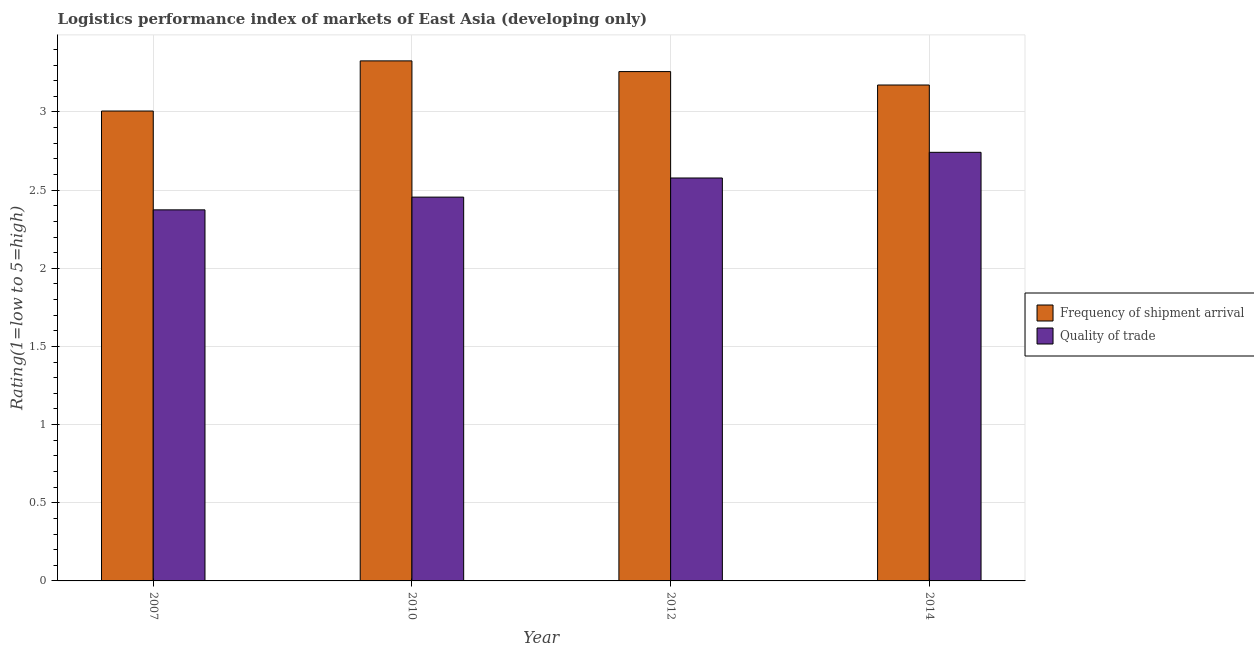How many different coloured bars are there?
Provide a succinct answer. 2. How many bars are there on the 3rd tick from the right?
Provide a succinct answer. 2. What is the lpi quality of trade in 2007?
Keep it short and to the point. 2.37. Across all years, what is the maximum lpi of frequency of shipment arrival?
Provide a succinct answer. 3.33. Across all years, what is the minimum lpi quality of trade?
Ensure brevity in your answer.  2.37. In which year was the lpi of frequency of shipment arrival minimum?
Ensure brevity in your answer.  2007. What is the total lpi of frequency of shipment arrival in the graph?
Your answer should be very brief. 12.76. What is the difference between the lpi of frequency of shipment arrival in 2012 and that in 2014?
Ensure brevity in your answer.  0.09. What is the difference between the lpi quality of trade in 2012 and the lpi of frequency of shipment arrival in 2010?
Your response must be concise. 0.12. What is the average lpi of frequency of shipment arrival per year?
Your answer should be very brief. 3.19. In the year 2014, what is the difference between the lpi of frequency of shipment arrival and lpi quality of trade?
Provide a succinct answer. 0. In how many years, is the lpi quality of trade greater than 0.2?
Give a very brief answer. 4. What is the ratio of the lpi of frequency of shipment arrival in 2007 to that in 2010?
Provide a succinct answer. 0.9. Is the lpi of frequency of shipment arrival in 2010 less than that in 2012?
Offer a terse response. No. What is the difference between the highest and the second highest lpi quality of trade?
Provide a short and direct response. 0.16. What is the difference between the highest and the lowest lpi of frequency of shipment arrival?
Offer a very short reply. 0.32. What does the 2nd bar from the left in 2007 represents?
Ensure brevity in your answer.  Quality of trade. What does the 2nd bar from the right in 2010 represents?
Ensure brevity in your answer.  Frequency of shipment arrival. How many bars are there?
Your response must be concise. 8. How many years are there in the graph?
Make the answer very short. 4. What is the difference between two consecutive major ticks on the Y-axis?
Keep it short and to the point. 0.5. Are the values on the major ticks of Y-axis written in scientific E-notation?
Your answer should be compact. No. Does the graph contain any zero values?
Give a very brief answer. No. Where does the legend appear in the graph?
Provide a short and direct response. Center right. How many legend labels are there?
Offer a very short reply. 2. What is the title of the graph?
Your answer should be very brief. Logistics performance index of markets of East Asia (developing only). What is the label or title of the X-axis?
Provide a short and direct response. Year. What is the label or title of the Y-axis?
Your answer should be very brief. Rating(1=low to 5=high). What is the Rating(1=low to 5=high) of Frequency of shipment arrival in 2007?
Provide a succinct answer. 3.01. What is the Rating(1=low to 5=high) in Quality of trade in 2007?
Offer a terse response. 2.37. What is the Rating(1=low to 5=high) of Frequency of shipment arrival in 2010?
Offer a very short reply. 3.33. What is the Rating(1=low to 5=high) of Quality of trade in 2010?
Your answer should be very brief. 2.46. What is the Rating(1=low to 5=high) of Frequency of shipment arrival in 2012?
Your answer should be compact. 3.26. What is the Rating(1=low to 5=high) of Quality of trade in 2012?
Give a very brief answer. 2.58. What is the Rating(1=low to 5=high) of Frequency of shipment arrival in 2014?
Your answer should be very brief. 3.17. What is the Rating(1=low to 5=high) of Quality of trade in 2014?
Provide a succinct answer. 2.74. Across all years, what is the maximum Rating(1=low to 5=high) in Frequency of shipment arrival?
Your answer should be compact. 3.33. Across all years, what is the maximum Rating(1=low to 5=high) in Quality of trade?
Offer a terse response. 2.74. Across all years, what is the minimum Rating(1=low to 5=high) of Frequency of shipment arrival?
Offer a terse response. 3.01. Across all years, what is the minimum Rating(1=low to 5=high) in Quality of trade?
Your response must be concise. 2.37. What is the total Rating(1=low to 5=high) of Frequency of shipment arrival in the graph?
Offer a very short reply. 12.76. What is the total Rating(1=low to 5=high) of Quality of trade in the graph?
Your answer should be very brief. 10.15. What is the difference between the Rating(1=low to 5=high) in Frequency of shipment arrival in 2007 and that in 2010?
Make the answer very short. -0.32. What is the difference between the Rating(1=low to 5=high) of Quality of trade in 2007 and that in 2010?
Provide a succinct answer. -0.08. What is the difference between the Rating(1=low to 5=high) in Frequency of shipment arrival in 2007 and that in 2012?
Your response must be concise. -0.25. What is the difference between the Rating(1=low to 5=high) of Quality of trade in 2007 and that in 2012?
Offer a terse response. -0.2. What is the difference between the Rating(1=low to 5=high) in Frequency of shipment arrival in 2007 and that in 2014?
Offer a very short reply. -0.17. What is the difference between the Rating(1=low to 5=high) in Quality of trade in 2007 and that in 2014?
Offer a terse response. -0.37. What is the difference between the Rating(1=low to 5=high) of Frequency of shipment arrival in 2010 and that in 2012?
Provide a succinct answer. 0.07. What is the difference between the Rating(1=low to 5=high) in Quality of trade in 2010 and that in 2012?
Provide a succinct answer. -0.12. What is the difference between the Rating(1=low to 5=high) in Frequency of shipment arrival in 2010 and that in 2014?
Give a very brief answer. 0.15. What is the difference between the Rating(1=low to 5=high) in Quality of trade in 2010 and that in 2014?
Make the answer very short. -0.29. What is the difference between the Rating(1=low to 5=high) in Frequency of shipment arrival in 2012 and that in 2014?
Offer a very short reply. 0.09. What is the difference between the Rating(1=low to 5=high) of Quality of trade in 2012 and that in 2014?
Offer a very short reply. -0.16. What is the difference between the Rating(1=low to 5=high) in Frequency of shipment arrival in 2007 and the Rating(1=low to 5=high) in Quality of trade in 2010?
Make the answer very short. 0.55. What is the difference between the Rating(1=low to 5=high) in Frequency of shipment arrival in 2007 and the Rating(1=low to 5=high) in Quality of trade in 2012?
Offer a very short reply. 0.43. What is the difference between the Rating(1=low to 5=high) in Frequency of shipment arrival in 2007 and the Rating(1=low to 5=high) in Quality of trade in 2014?
Provide a succinct answer. 0.26. What is the difference between the Rating(1=low to 5=high) of Frequency of shipment arrival in 2010 and the Rating(1=low to 5=high) of Quality of trade in 2012?
Make the answer very short. 0.75. What is the difference between the Rating(1=low to 5=high) in Frequency of shipment arrival in 2010 and the Rating(1=low to 5=high) in Quality of trade in 2014?
Provide a succinct answer. 0.58. What is the difference between the Rating(1=low to 5=high) of Frequency of shipment arrival in 2012 and the Rating(1=low to 5=high) of Quality of trade in 2014?
Ensure brevity in your answer.  0.52. What is the average Rating(1=low to 5=high) of Frequency of shipment arrival per year?
Your answer should be compact. 3.19. What is the average Rating(1=low to 5=high) of Quality of trade per year?
Your response must be concise. 2.54. In the year 2007, what is the difference between the Rating(1=low to 5=high) in Frequency of shipment arrival and Rating(1=low to 5=high) in Quality of trade?
Provide a short and direct response. 0.63. In the year 2010, what is the difference between the Rating(1=low to 5=high) of Frequency of shipment arrival and Rating(1=low to 5=high) of Quality of trade?
Offer a very short reply. 0.87. In the year 2012, what is the difference between the Rating(1=low to 5=high) in Frequency of shipment arrival and Rating(1=low to 5=high) in Quality of trade?
Give a very brief answer. 0.68. In the year 2014, what is the difference between the Rating(1=low to 5=high) in Frequency of shipment arrival and Rating(1=low to 5=high) in Quality of trade?
Your answer should be very brief. 0.43. What is the ratio of the Rating(1=low to 5=high) of Frequency of shipment arrival in 2007 to that in 2010?
Give a very brief answer. 0.9. What is the ratio of the Rating(1=low to 5=high) in Quality of trade in 2007 to that in 2010?
Offer a terse response. 0.97. What is the ratio of the Rating(1=low to 5=high) of Frequency of shipment arrival in 2007 to that in 2012?
Offer a terse response. 0.92. What is the ratio of the Rating(1=low to 5=high) of Quality of trade in 2007 to that in 2012?
Ensure brevity in your answer.  0.92. What is the ratio of the Rating(1=low to 5=high) in Frequency of shipment arrival in 2007 to that in 2014?
Offer a terse response. 0.95. What is the ratio of the Rating(1=low to 5=high) of Quality of trade in 2007 to that in 2014?
Your answer should be very brief. 0.87. What is the ratio of the Rating(1=low to 5=high) of Quality of trade in 2010 to that in 2012?
Ensure brevity in your answer.  0.95. What is the ratio of the Rating(1=low to 5=high) of Frequency of shipment arrival in 2010 to that in 2014?
Ensure brevity in your answer.  1.05. What is the ratio of the Rating(1=low to 5=high) of Quality of trade in 2010 to that in 2014?
Ensure brevity in your answer.  0.9. What is the ratio of the Rating(1=low to 5=high) in Frequency of shipment arrival in 2012 to that in 2014?
Your response must be concise. 1.03. What is the ratio of the Rating(1=low to 5=high) in Quality of trade in 2012 to that in 2014?
Make the answer very short. 0.94. What is the difference between the highest and the second highest Rating(1=low to 5=high) of Frequency of shipment arrival?
Your answer should be compact. 0.07. What is the difference between the highest and the second highest Rating(1=low to 5=high) in Quality of trade?
Make the answer very short. 0.16. What is the difference between the highest and the lowest Rating(1=low to 5=high) in Frequency of shipment arrival?
Your response must be concise. 0.32. What is the difference between the highest and the lowest Rating(1=low to 5=high) of Quality of trade?
Keep it short and to the point. 0.37. 